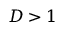Convert formula to latex. <formula><loc_0><loc_0><loc_500><loc_500>D > 1</formula> 